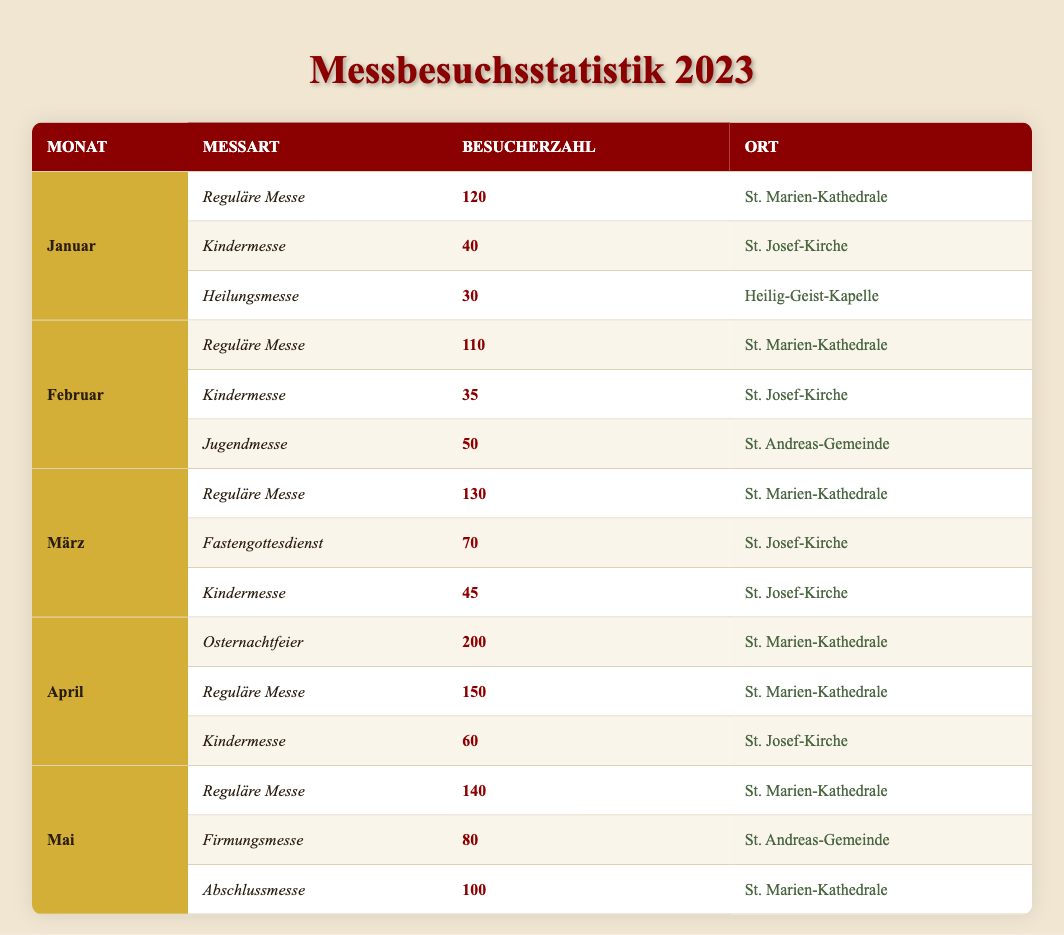What was the attendance for the Regular Mass in April? From the table, in April, the attendance for the Regular Mass is specifically listed as 150.
Answer: 150 How many different types of masses were held in February? The table shows three types of masses for February: Regular Mass, Children's Mass, and Youth Mass, which indicates that there are three different types of masses.
Answer: 3 Which mass type had the highest attendance in January? In January, the Regular Mass had the highest attendance of 120, compared to the Children's Mass with 40 and the Healing Mass with 30.
Answer: Regular Mass What is the total attendance for all mass types in March? To find the total for March, we sum the attendance of each mass type: Regular Mass (130) + Lenten Service (70) + Children's Mass (45) = 245.
Answer: 245 Did the Children's Mass have more attendees than the Healing Mass in January? In January, the Children's Mass had 40 attendees, whereas the Healing Mass had 30 attendees, thus the Children's Mass had more attendees.
Answer: Yes What is the average attendance for the Regular Mass across the five months? The attendances for Regular Mass over the five months are: January (120), February (110), March (130), April (150), and May (140). The average is calculated as (120 + 110 + 130 + 150 + 140) / 5 = 130.
Answer: 130 Which month had the highest overall attendance for all masses combined? We analyze the total attendance for each month: January (120 + 40 + 30 = 190), February (110 + 35 + 50 = 195), March (130 + 70 + 45 = 245), April (200 + 150 + 60 = 410), and May (140 + 80 + 100 = 320). April has the highest total at 410.
Answer: April Was the Easter Vigil Mass held at St. Mary's Cathedral? According to the table, the Easter Vigil in April is listed as being held at St. Mary's Cathedral, confirming the fact.
Answer: Yes How does the attendance at the Healing Mass in January compare to that in February? The attendance at the Healing Mass in January is 30, while in February there is no Healing Mass recorded, implying attendance of 0. Therefore, January has higher attendance.
Answer: Higher in January 